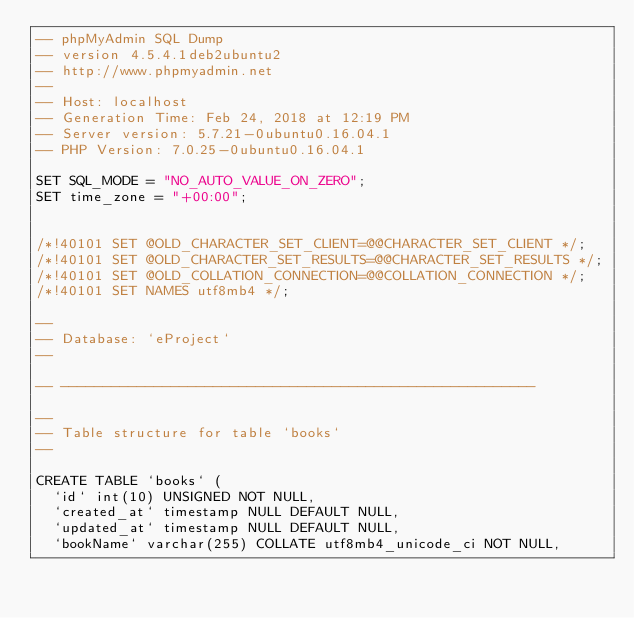Convert code to text. <code><loc_0><loc_0><loc_500><loc_500><_SQL_>-- phpMyAdmin SQL Dump
-- version 4.5.4.1deb2ubuntu2
-- http://www.phpmyadmin.net
--
-- Host: localhost
-- Generation Time: Feb 24, 2018 at 12:19 PM
-- Server version: 5.7.21-0ubuntu0.16.04.1
-- PHP Version: 7.0.25-0ubuntu0.16.04.1

SET SQL_MODE = "NO_AUTO_VALUE_ON_ZERO";
SET time_zone = "+00:00";


/*!40101 SET @OLD_CHARACTER_SET_CLIENT=@@CHARACTER_SET_CLIENT */;
/*!40101 SET @OLD_CHARACTER_SET_RESULTS=@@CHARACTER_SET_RESULTS */;
/*!40101 SET @OLD_COLLATION_CONNECTION=@@COLLATION_CONNECTION */;
/*!40101 SET NAMES utf8mb4 */;

--
-- Database: `eProject`
--

-- --------------------------------------------------------

--
-- Table structure for table `books`
--

CREATE TABLE `books` (
  `id` int(10) UNSIGNED NOT NULL,
  `created_at` timestamp NULL DEFAULT NULL,
  `updated_at` timestamp NULL DEFAULT NULL,
  `bookName` varchar(255) COLLATE utf8mb4_unicode_ci NOT NULL,</code> 